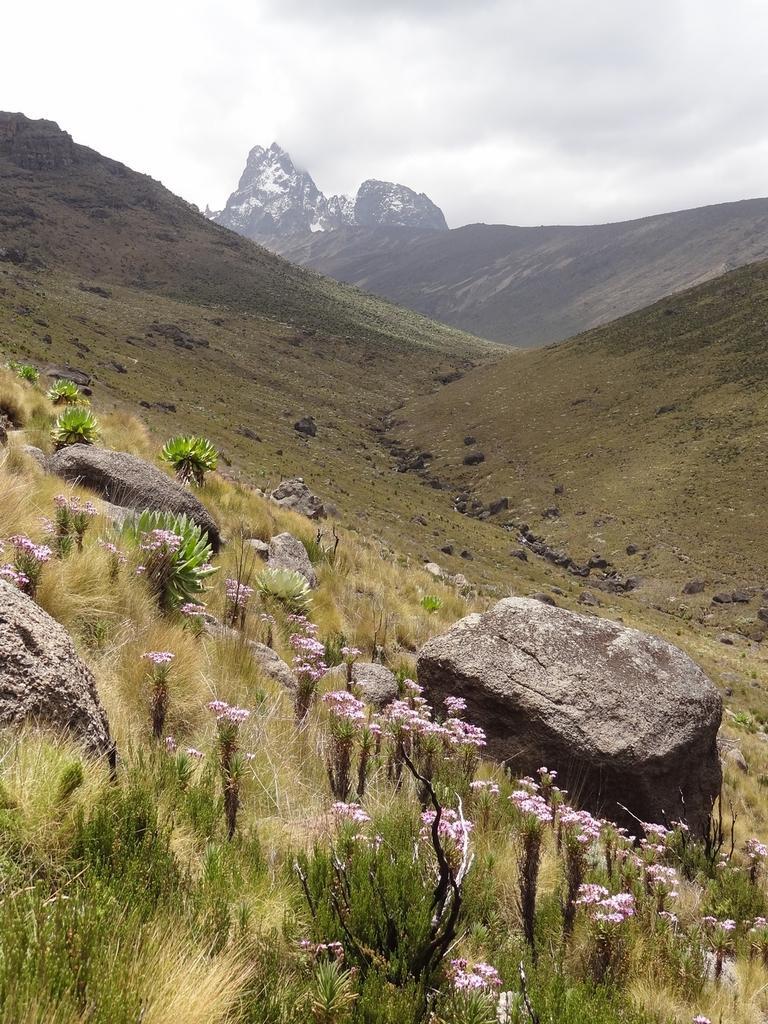Could you give a brief overview of what you see in this image? In the foreground there are flowers, plants, stones and grass. In the middle of the picture there are hills and mountain. At the top there is sky. 